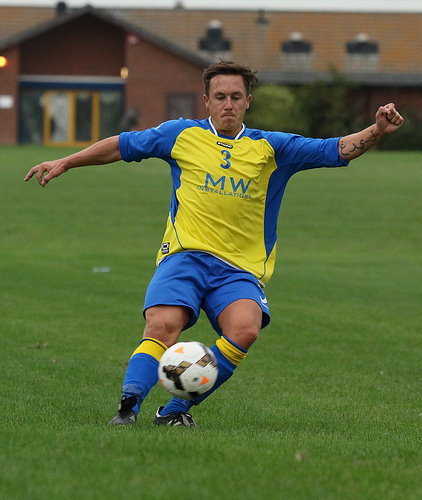<image>
Is there a ball next to the man? Yes. The ball is positioned adjacent to the man, located nearby in the same general area. 